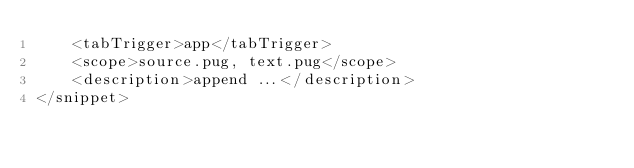<code> <loc_0><loc_0><loc_500><loc_500><_XML_>    <tabTrigger>app</tabTrigger>
    <scope>source.pug, text.pug</scope>
    <description>append ...</description>
</snippet>
</code> 